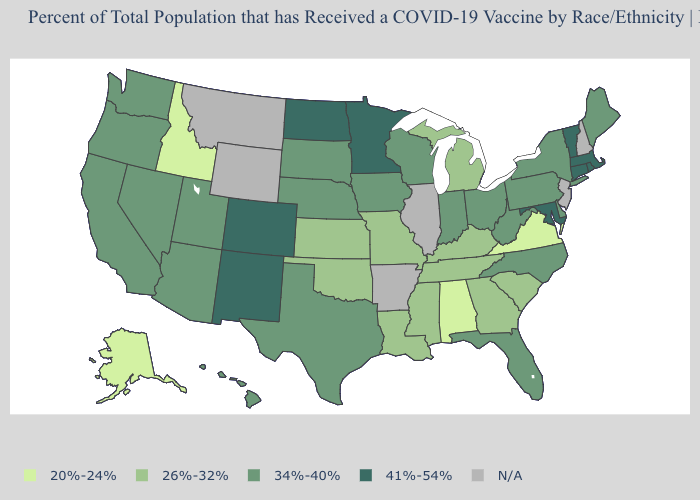What is the lowest value in the Northeast?
Keep it brief. 34%-40%. Name the states that have a value in the range 26%-32%?
Be succinct. Georgia, Kansas, Kentucky, Louisiana, Michigan, Mississippi, Missouri, Oklahoma, South Carolina, Tennessee. What is the value of New York?
Write a very short answer. 34%-40%. What is the highest value in the USA?
Answer briefly. 41%-54%. Among the states that border Vermont , which have the highest value?
Concise answer only. Massachusetts. What is the highest value in the Northeast ?
Write a very short answer. 41%-54%. Is the legend a continuous bar?
Give a very brief answer. No. Name the states that have a value in the range 20%-24%?
Be succinct. Alabama, Alaska, Idaho, Virginia. What is the highest value in the West ?
Answer briefly. 41%-54%. Does the map have missing data?
Answer briefly. Yes. How many symbols are there in the legend?
Keep it brief. 5. Does Virginia have the lowest value in the USA?
Answer briefly. Yes. What is the highest value in the South ?
Quick response, please. 41%-54%. Does the map have missing data?
Answer briefly. Yes. What is the value of Hawaii?
Keep it brief. 34%-40%. 